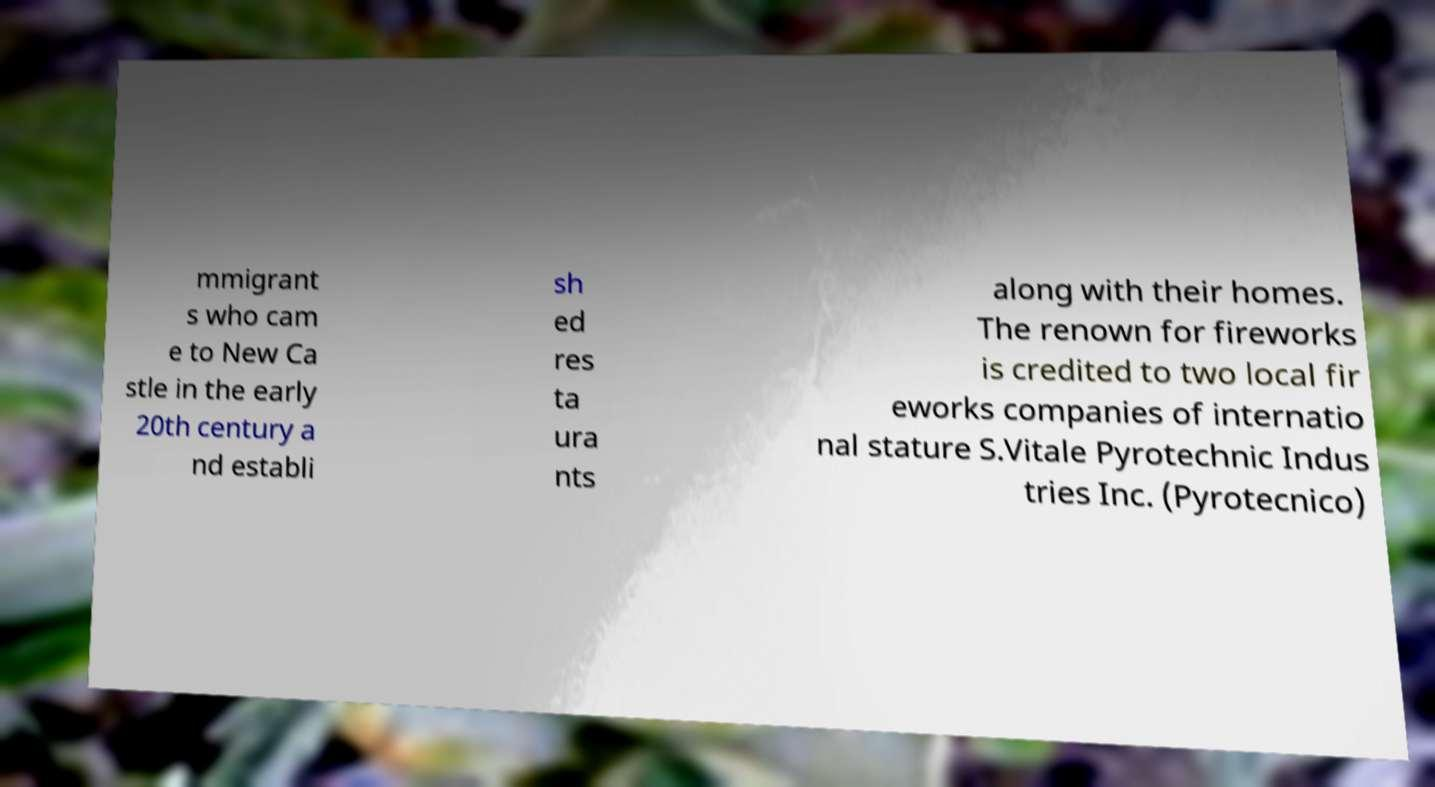Can you read and provide the text displayed in the image?This photo seems to have some interesting text. Can you extract and type it out for me? mmigrant s who cam e to New Ca stle in the early 20th century a nd establi sh ed res ta ura nts along with their homes. The renown for fireworks is credited to two local fir eworks companies of internatio nal stature S.Vitale Pyrotechnic Indus tries Inc. (Pyrotecnico) 